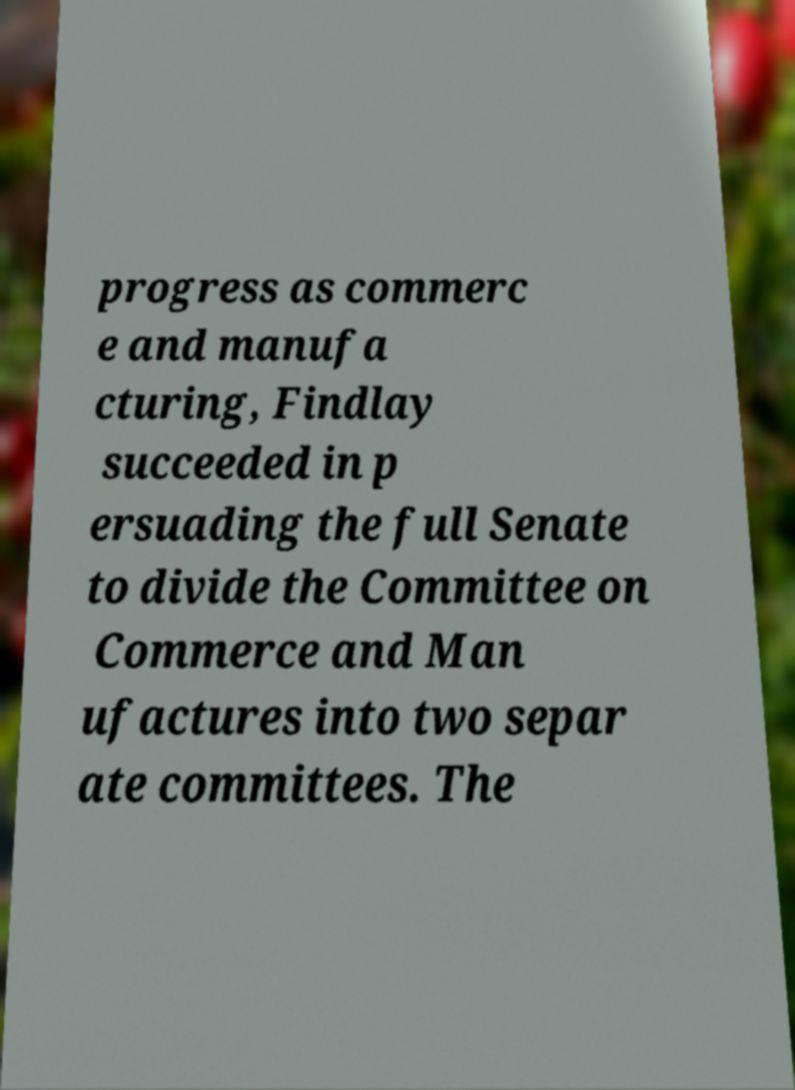Could you assist in decoding the text presented in this image and type it out clearly? progress as commerc e and manufa cturing, Findlay succeeded in p ersuading the full Senate to divide the Committee on Commerce and Man ufactures into two separ ate committees. The 